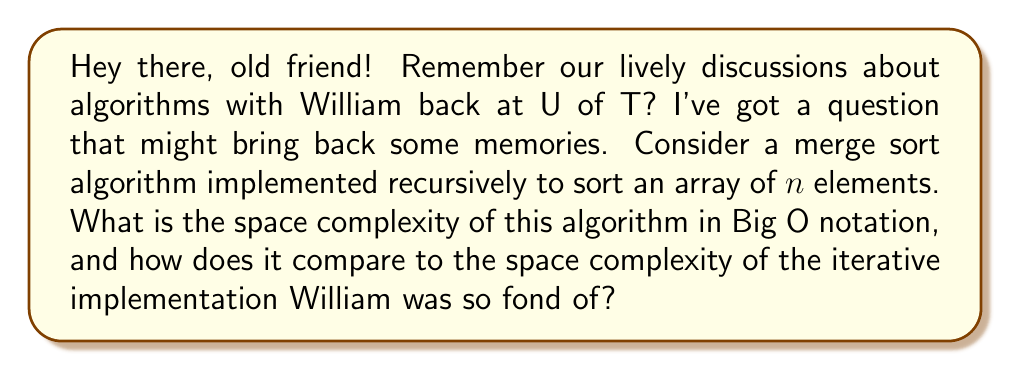Give your solution to this math problem. Let's break this down step-by-step, just like we used to do in our study sessions:

1) Recursive Merge Sort:
   - The recursive merge sort algorithm divides the array into two halves at each step.
   - It uses additional space for merging the sorted subarrays.
   - At any given time, there are at most $O(\log n)$ recursive calls on the stack, because the depth of the recursion tree is $\log_2 n$.
   - Each recursive call uses $O(1)$ space for local variables.
   - The merging step requires an auxiliary array of size $n$.

   Therefore, the total space complexity is:
   $$O(n + \log n) = O(n)$$

2) Iterative Merge Sort:
   - The iterative version William liked uses a bottom-up approach.
   - It still requires an auxiliary array of size $n$ for merging.
   - However, it doesn't use the call stack for recursion.

   So, the space complexity for the iterative version is:
   $$O(n)$$

3) Comparison:
   Both implementations have the same asymptotic space complexity of $O(n)$. However, the recursive version uses additional space on the call stack, which is bounded by $O(\log n)$. In practice, the iterative version might use slightly less space, which is probably why William preferred it.

It's worth noting that while both have $O(n)$ space complexity, the recursive version's space usage is more distributed (between the heap and the stack), while the iterative version's space usage is concentrated on the heap.
Answer: The space complexity of the recursive merge sort algorithm is $O(n)$, which is the same as the iterative implementation. However, the recursive version uses additional $O(\log n)$ space on the call stack, making it slightly less space-efficient in practice. 